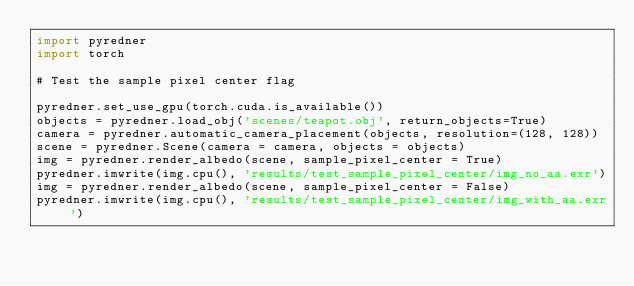<code> <loc_0><loc_0><loc_500><loc_500><_Python_>import pyredner
import torch

# Test the sample pixel center flag

pyredner.set_use_gpu(torch.cuda.is_available())
objects = pyredner.load_obj('scenes/teapot.obj', return_objects=True)
camera = pyredner.automatic_camera_placement(objects, resolution=(128, 128))
scene = pyredner.Scene(camera = camera, objects = objects)
img = pyredner.render_albedo(scene, sample_pixel_center = True)
pyredner.imwrite(img.cpu(), 'results/test_sample_pixel_center/img_no_aa.exr')
img = pyredner.render_albedo(scene, sample_pixel_center = False)
pyredner.imwrite(img.cpu(), 'results/test_sample_pixel_center/img_with_aa.exr')</code> 